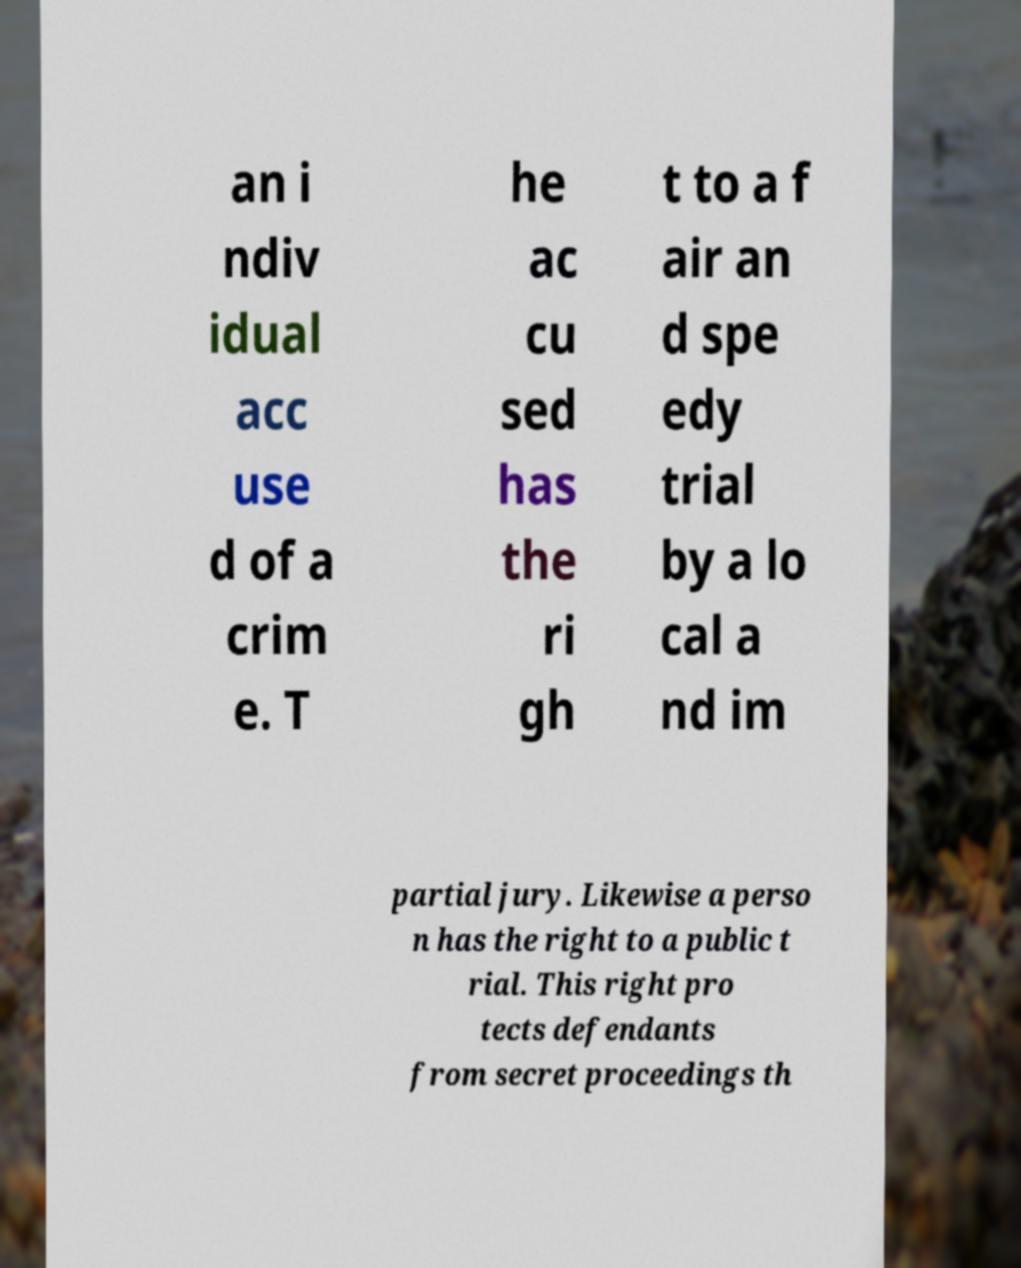What messages or text are displayed in this image? I need them in a readable, typed format. an i ndiv idual acc use d of a crim e. T he ac cu sed has the ri gh t to a f air an d spe edy trial by a lo cal a nd im partial jury. Likewise a perso n has the right to a public t rial. This right pro tects defendants from secret proceedings th 